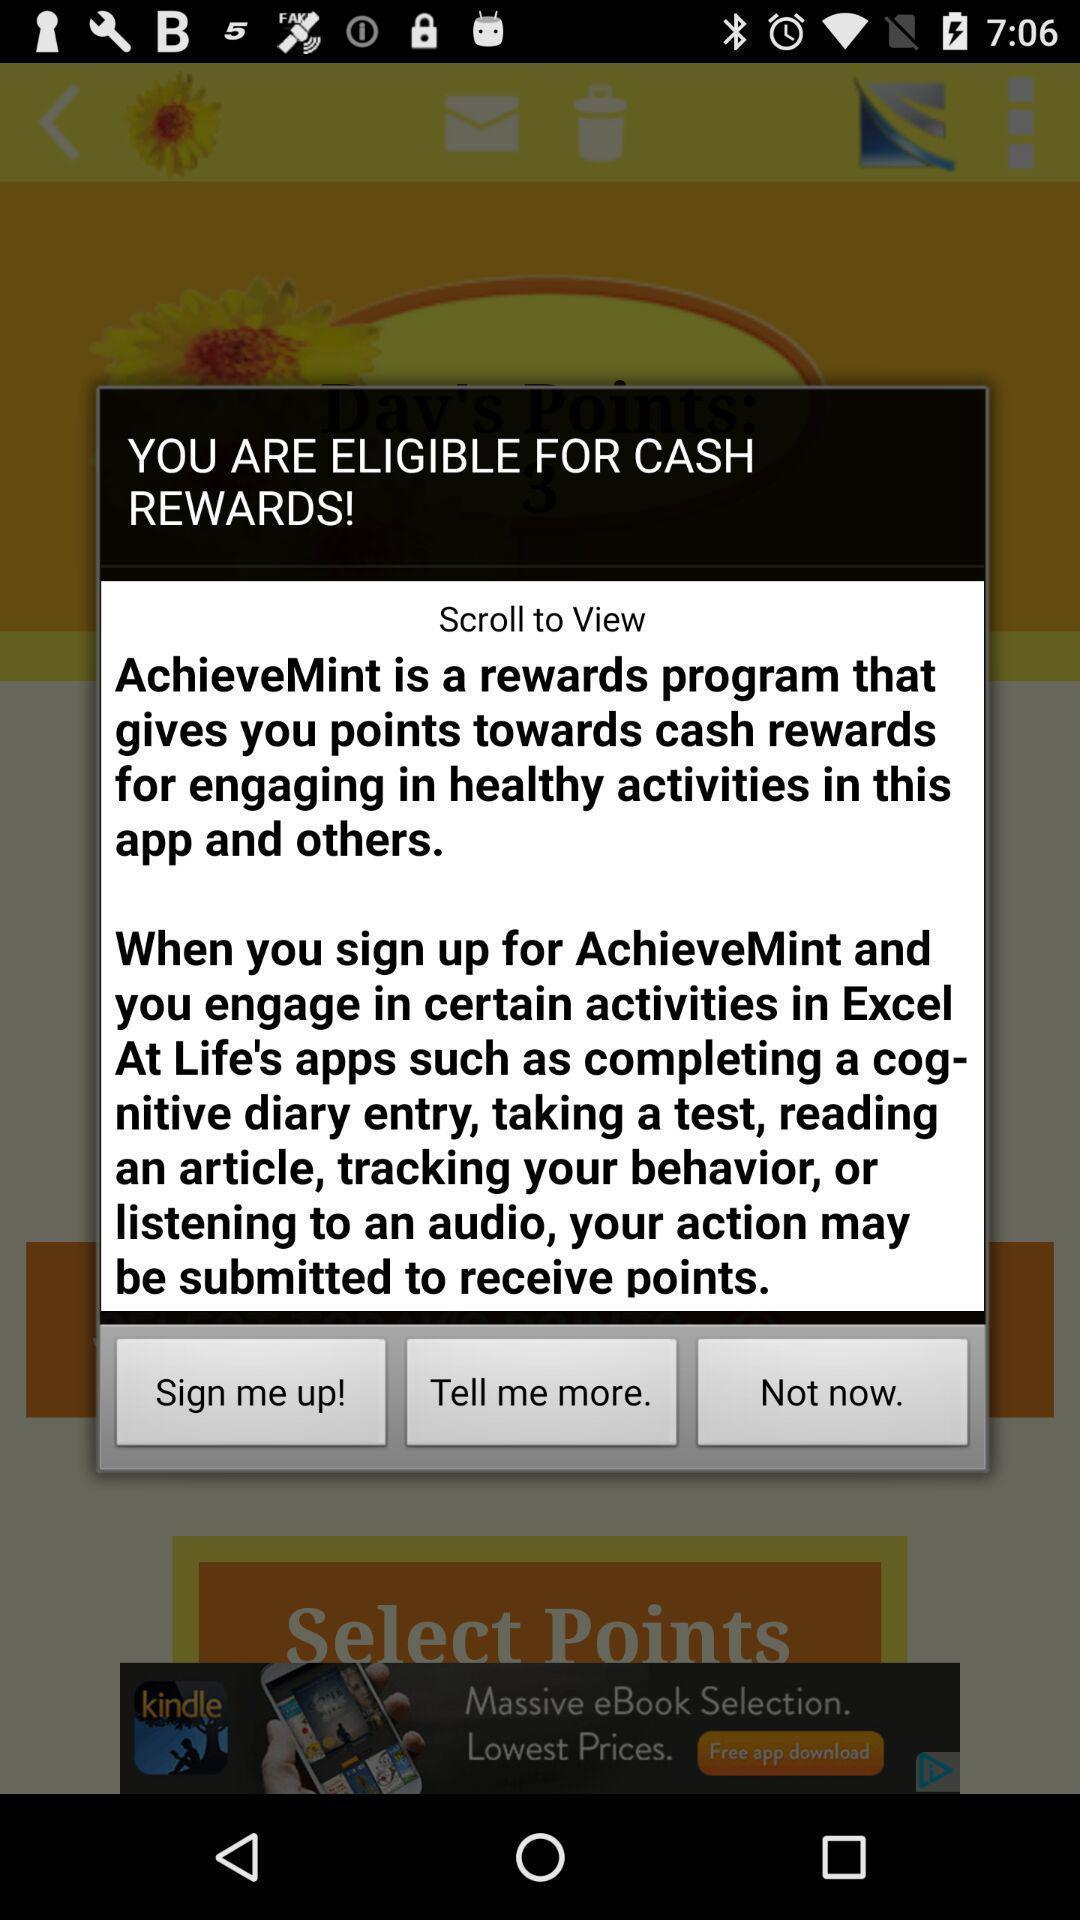Give me a narrative description of this picture. Pop-up shows information about rewards. 